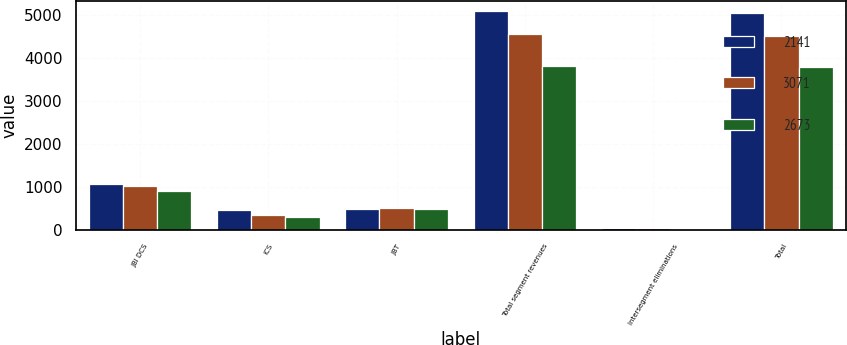<chart> <loc_0><loc_0><loc_500><loc_500><stacked_bar_chart><ecel><fcel>JBI DCS<fcel>ICS<fcel>JBT<fcel>Total segment revenues<fcel>Intersegment eliminations<fcel>Total<nl><fcel>2141<fcel>1080<fcel>456<fcel>484<fcel>5091<fcel>36<fcel>5055<nl><fcel>3071<fcel>1031<fcel>356<fcel>504<fcel>4564<fcel>37<fcel>4527<nl><fcel>2673<fcel>907<fcel>291<fcel>479<fcel>3818<fcel>25<fcel>3793<nl></chart> 